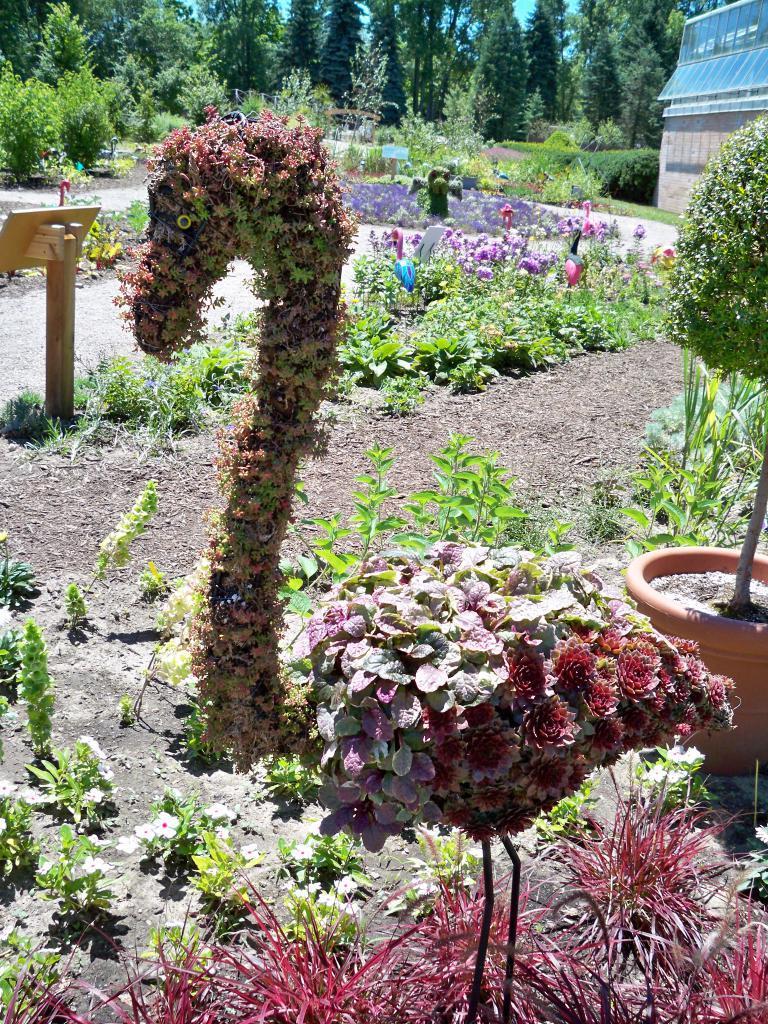Could you give a brief overview of what you see in this image? In this picture we can see some flowers and plants here, at the right top of the picture we can see a house, in the background there are some trees. 